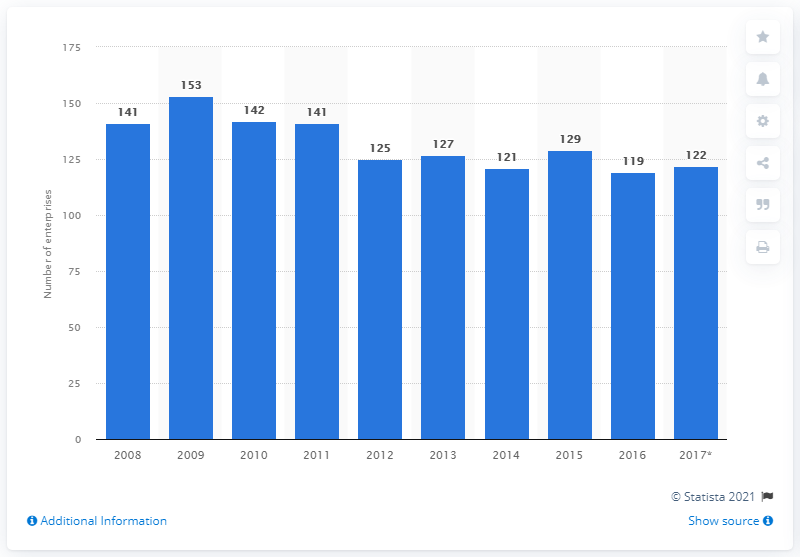Outline some significant characteristics in this image. In 2016, there were 119 enterprises in Bulgaria that manufactured glass and glass products. 